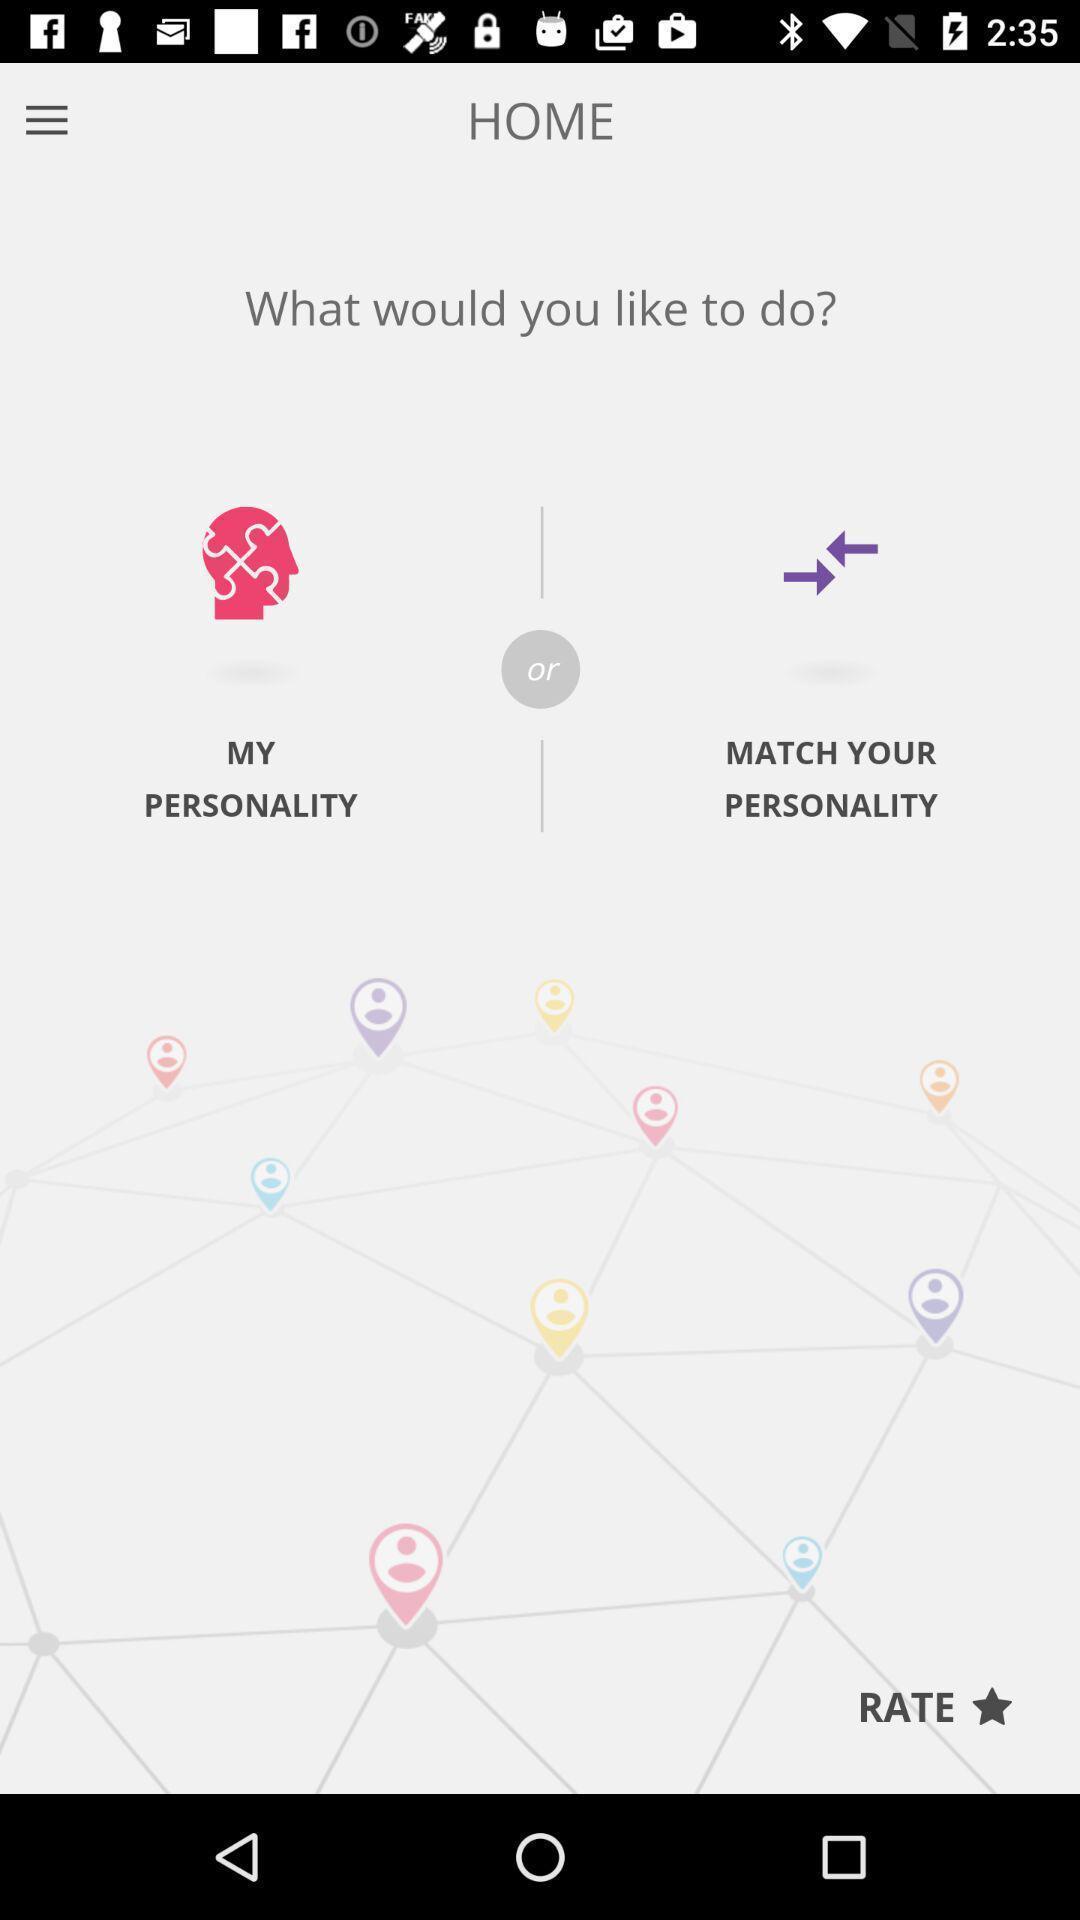Explain the elements present in this screenshot. Window displaying a personality test. 